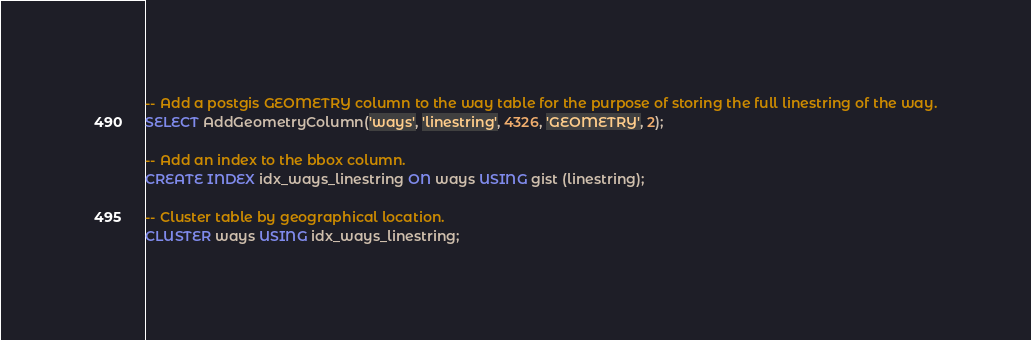Convert code to text. <code><loc_0><loc_0><loc_500><loc_500><_SQL_>-- Add a postgis GEOMETRY column to the way table for the purpose of storing the full linestring of the way.
SELECT AddGeometryColumn('ways', 'linestring', 4326, 'GEOMETRY', 2);

-- Add an index to the bbox column.
CREATE INDEX idx_ways_linestring ON ways USING gist (linestring);

-- Cluster table by geographical location.
CLUSTER ways USING idx_ways_linestring;
</code> 